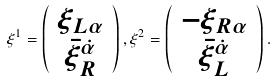Convert formula to latex. <formula><loc_0><loc_0><loc_500><loc_500>\xi ^ { 1 } = \left ( \begin{array} { c } \xi _ { L \alpha } \\ \bar { \xi } _ { R } ^ { \dot { \alpha } } \end{array} \right ) , \xi ^ { 2 } = \left ( \begin{array} { c } - \xi _ { R \alpha } \\ \bar { \xi } _ { L } ^ { \dot { \alpha } } \end{array} \right ) .</formula> 